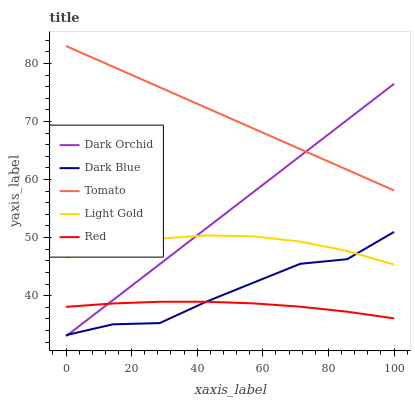Does Red have the minimum area under the curve?
Answer yes or no. Yes. Does Tomato have the maximum area under the curve?
Answer yes or no. Yes. Does Dark Blue have the minimum area under the curve?
Answer yes or no. No. Does Dark Blue have the maximum area under the curve?
Answer yes or no. No. Is Tomato the smoothest?
Answer yes or no. Yes. Is Dark Blue the roughest?
Answer yes or no. Yes. Is Light Gold the smoothest?
Answer yes or no. No. Is Light Gold the roughest?
Answer yes or no. No. Does Dark Orchid have the lowest value?
Answer yes or no. Yes. Does Dark Blue have the lowest value?
Answer yes or no. No. Does Tomato have the highest value?
Answer yes or no. Yes. Does Dark Blue have the highest value?
Answer yes or no. No. Is Light Gold less than Tomato?
Answer yes or no. Yes. Is Tomato greater than Light Gold?
Answer yes or no. Yes. Does Tomato intersect Dark Orchid?
Answer yes or no. Yes. Is Tomato less than Dark Orchid?
Answer yes or no. No. Is Tomato greater than Dark Orchid?
Answer yes or no. No. Does Light Gold intersect Tomato?
Answer yes or no. No. 